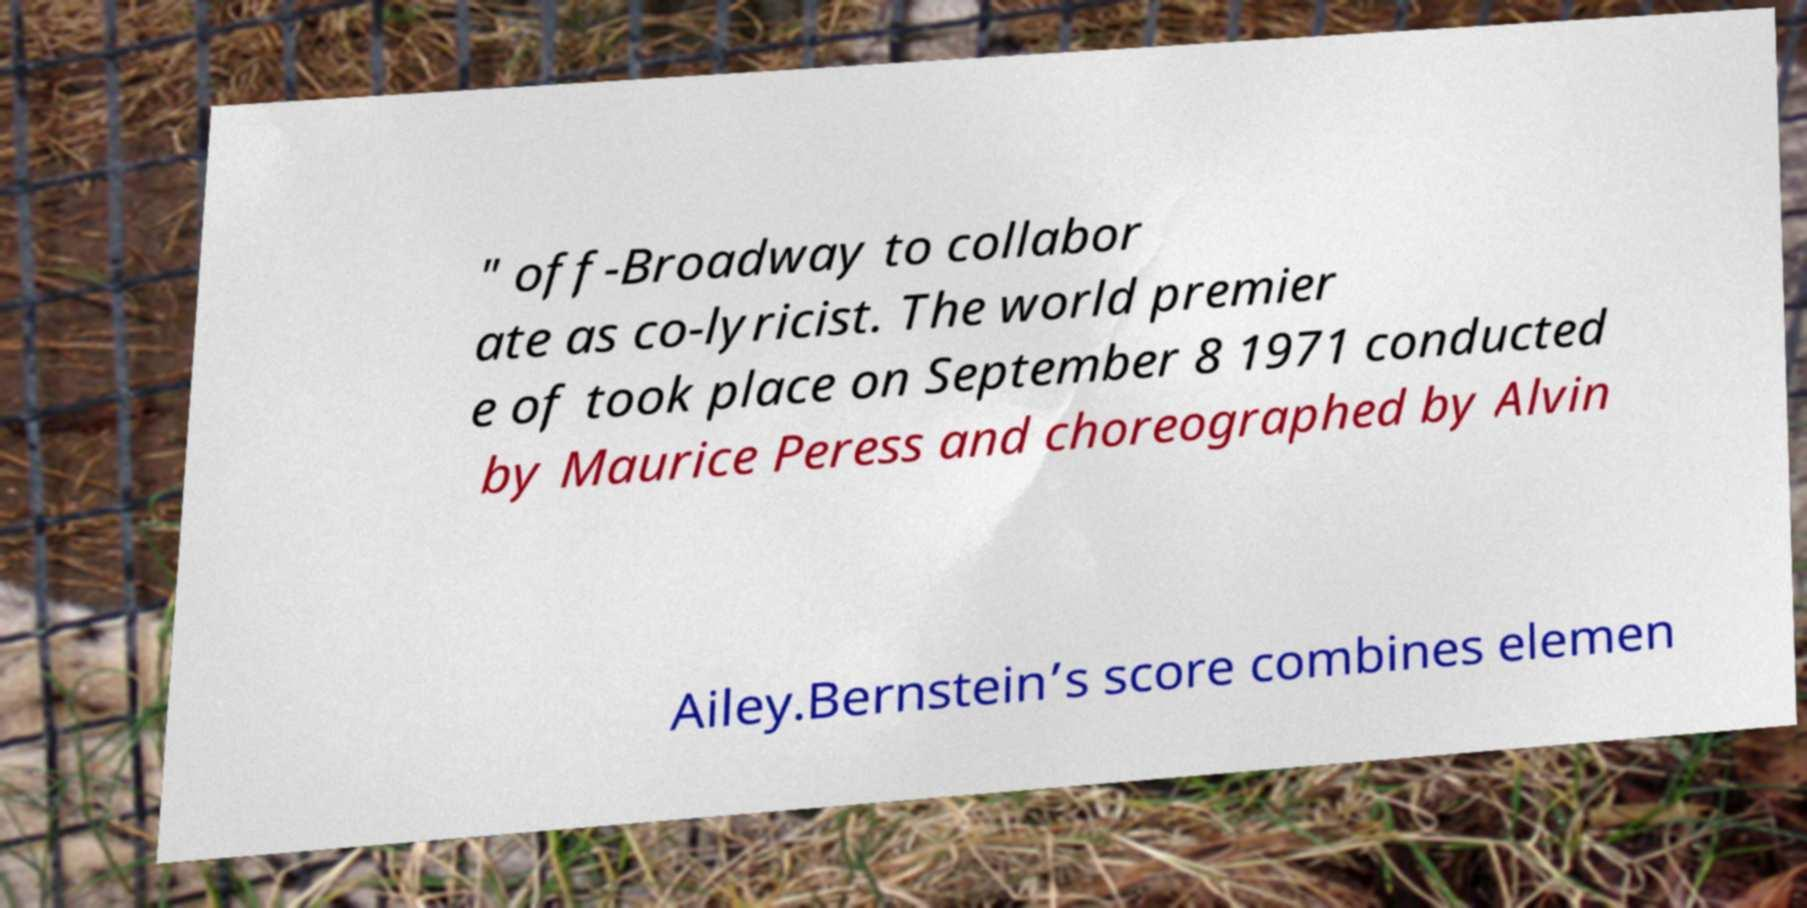Can you accurately transcribe the text from the provided image for me? " off-Broadway to collabor ate as co-lyricist. The world premier e of took place on September 8 1971 conducted by Maurice Peress and choreographed by Alvin Ailey.Bernstein’s score combines elemen 